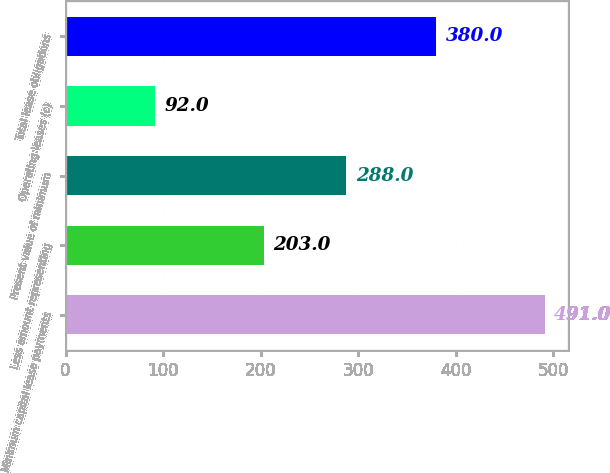Convert chart to OTSL. <chart><loc_0><loc_0><loc_500><loc_500><bar_chart><fcel>Minimum capital lease payments<fcel>Less amount representing<fcel>Present value of minimum<fcel>Operating leases (c)<fcel>Total lease obligations<nl><fcel>491<fcel>203<fcel>288<fcel>92<fcel>380<nl></chart> 